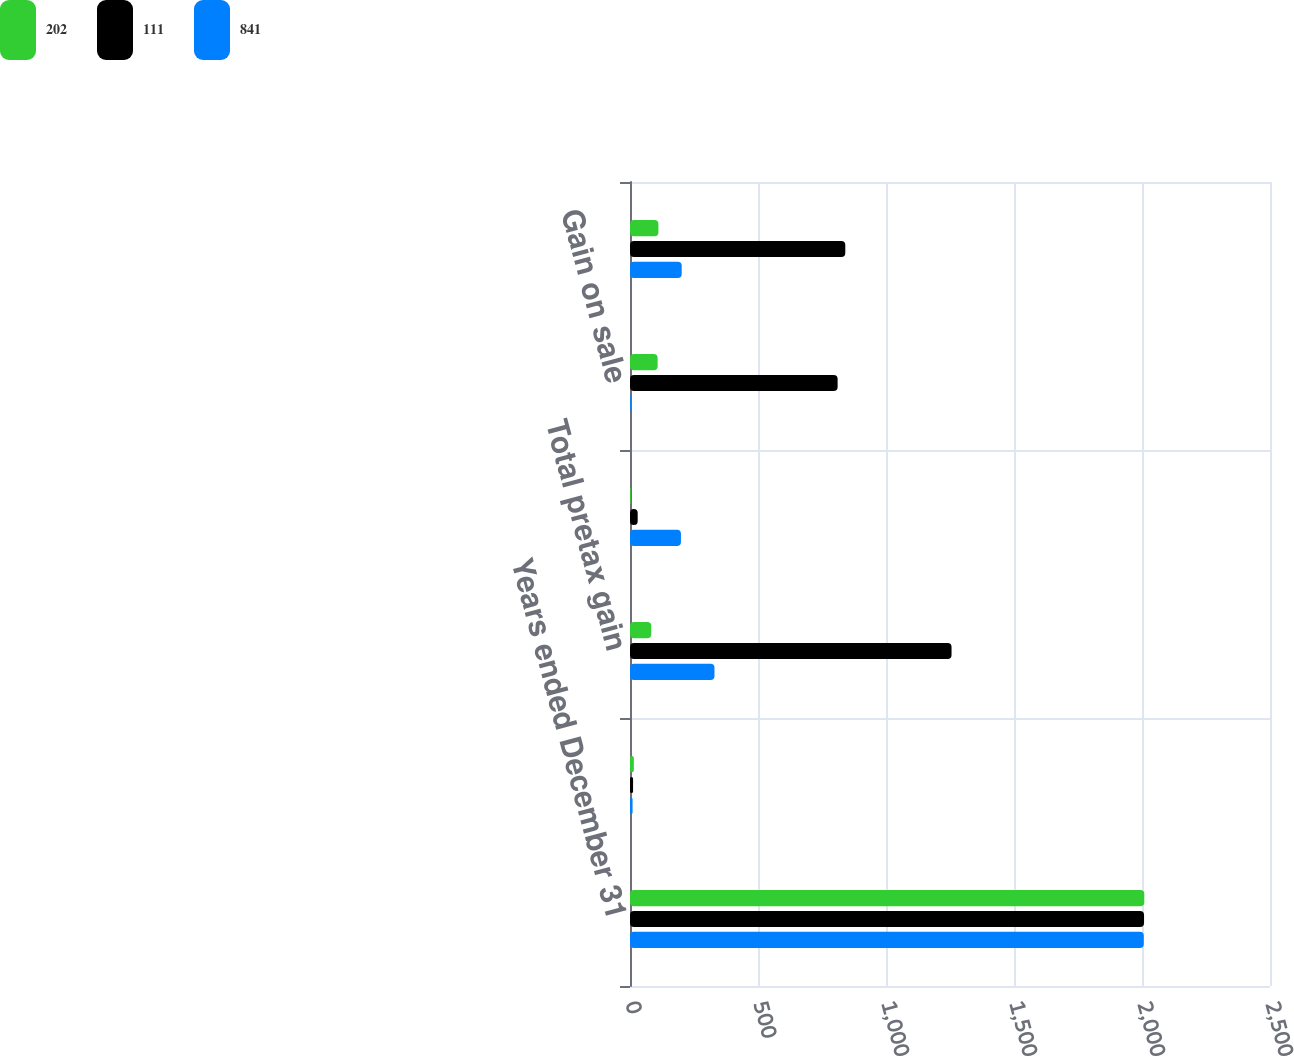<chart> <loc_0><loc_0><loc_500><loc_500><stacked_bar_chart><ecel><fcel>Years ended December 31<fcel>Other<fcel>Total pretax gain<fcel>Operations<fcel>Gain on sale<fcel>Total<nl><fcel>202<fcel>2009<fcel>15<fcel>83<fcel>3<fcel>108<fcel>111<nl><fcel>111<fcel>2008<fcel>12<fcel>1256<fcel>30<fcel>811<fcel>841<nl><fcel>841<fcel>2007<fcel>10<fcel>330<fcel>199<fcel>3<fcel>202<nl></chart> 